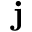<formula> <loc_0><loc_0><loc_500><loc_500>j</formula> 